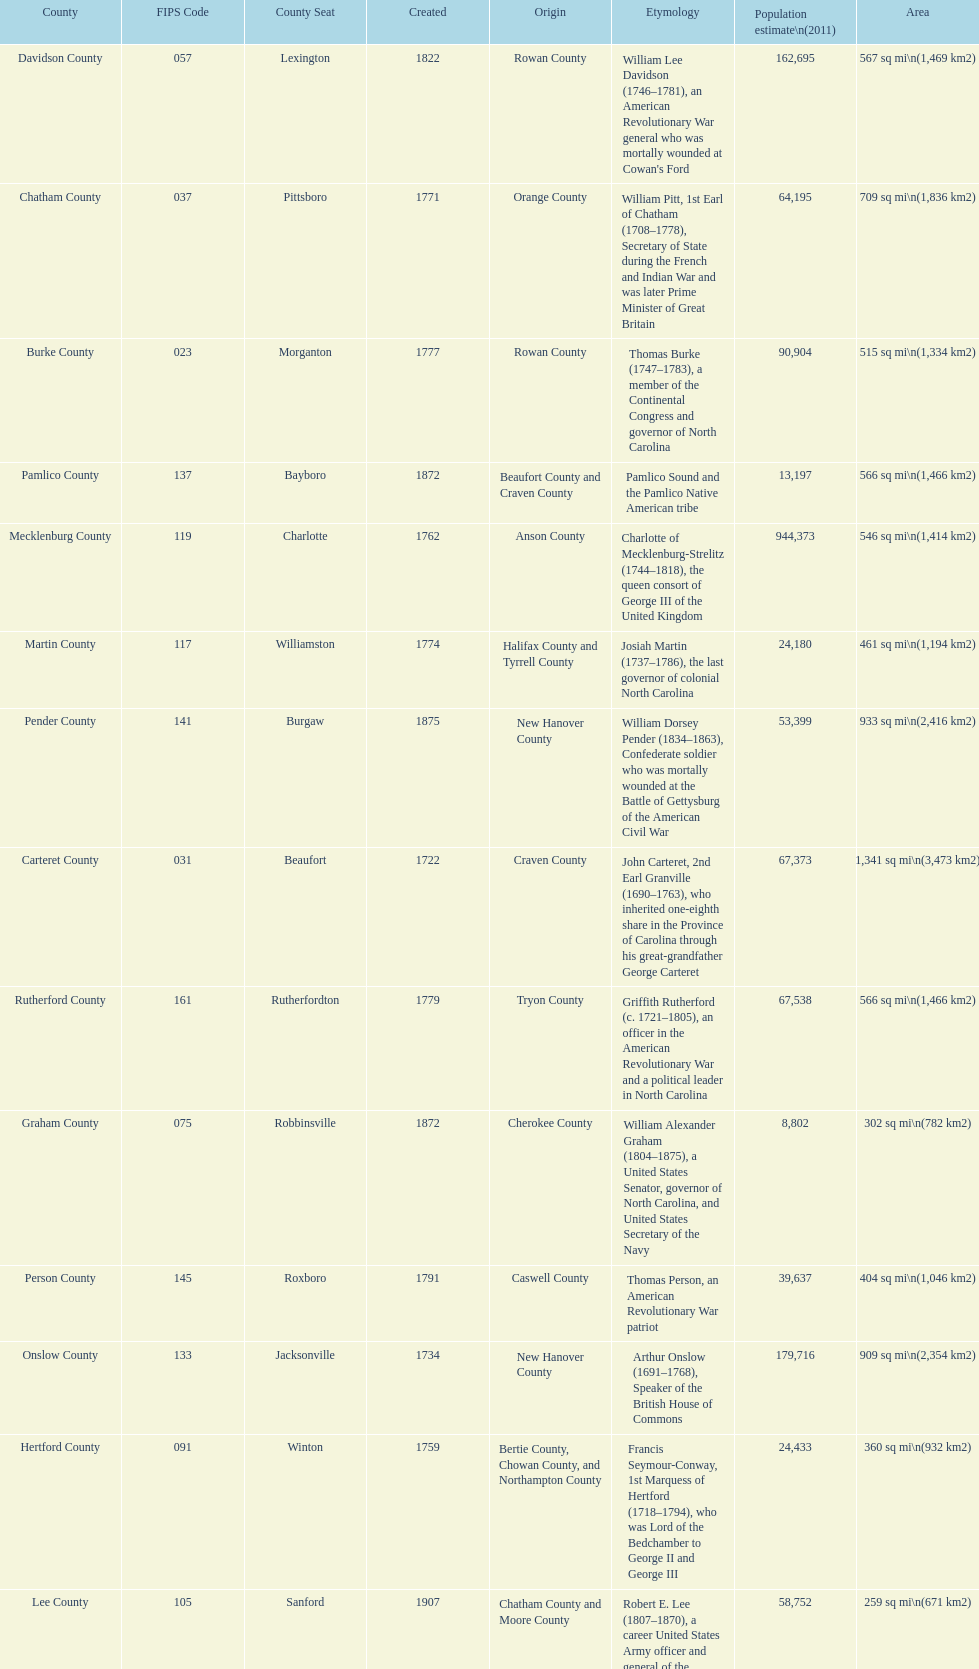What is the total number of counties listed? 100. 